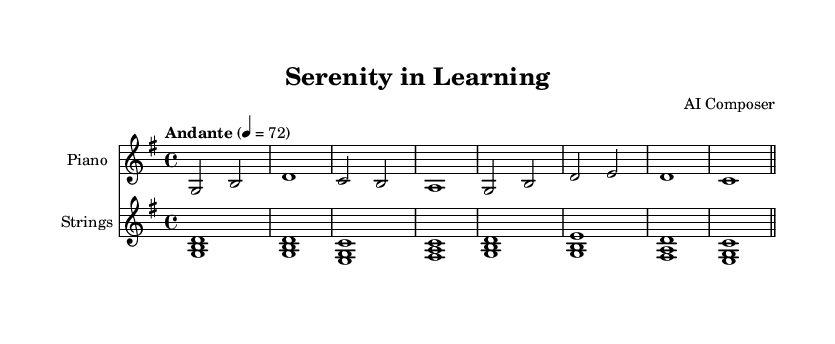What is the key signature of this music? The key signature indicated at the beginning of the sheet music shows one sharp, which corresponds to D major or B minor, but since the music is described in the context of meditation and learning, it is likely in D major.
Answer: D major What is the time signature of the piece? The time signature is indicated in the first measure as 4/4, which means there are four beats in each measure and a quarter note receives one beat.
Answer: 4/4 What is the tempo marking of this piece? The tempo marking is given as "Andante" with a metronome marking of 72, indicating a moderate tempo suitable for reflection and focus.
Answer: Andante How many measures are in the piano part? Counting the measures in the piano part, there are 8 measures total in the provided excerpt of the sheet music.
Answer: 8 Which instruments are specified in the score? The score specifically names two instruments: Piano and Strings. This information is shown at the beginning of their respective staff sections in the sheet music.
Answer: Piano and Strings What is the main thematic chord used in the strings? The strings part primarily features chords built around G major, as the first chord is a G major triad, establishing the tonal center.
Answer: G major What is the significance of the music being described as "Instrumental Christian meditation music"? The music's gentle rhythm and tonal quality are designed to promote focus and a meditative state, aligning with the purpose of fostering a calm and reflective environment conducive for online training.
Answer: Calm and reflective 